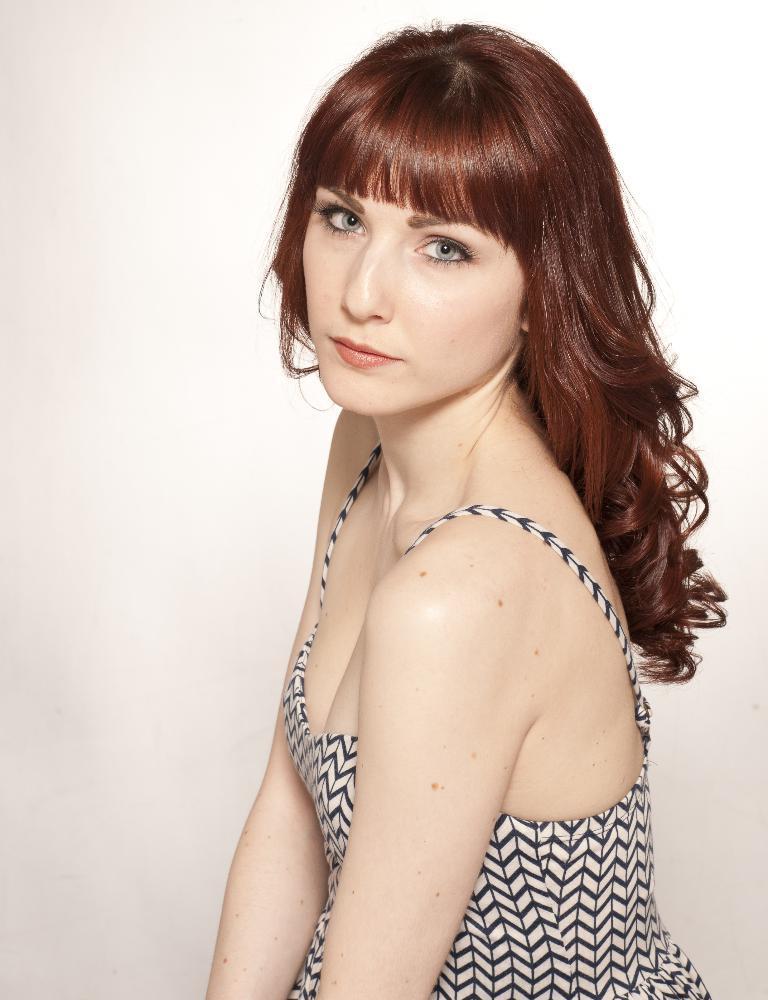How would you summarize this image in a sentence or two? In this image we can see a woman with long hair wearing a dress. 